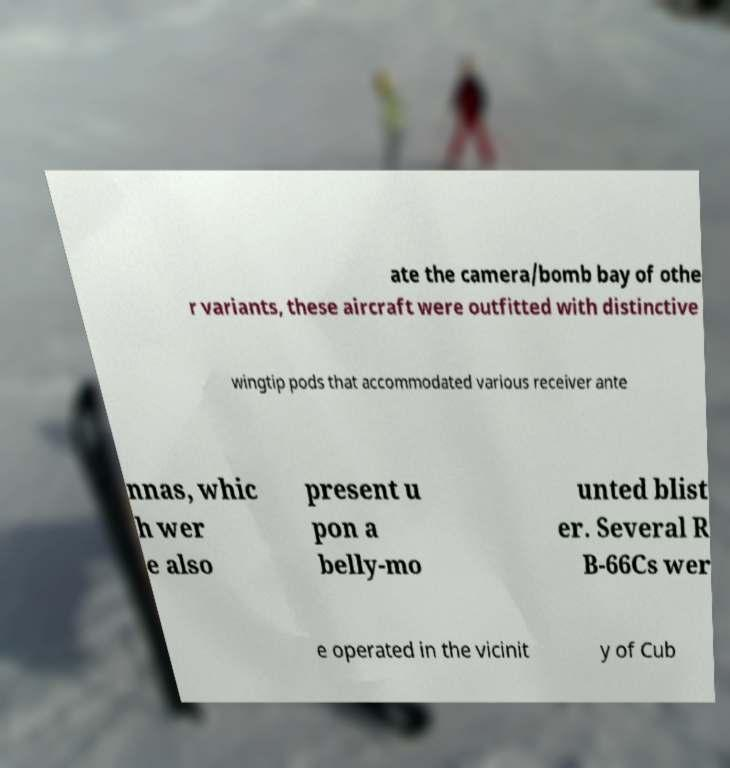I need the written content from this picture converted into text. Can you do that? ate the camera/bomb bay of othe r variants, these aircraft were outfitted with distinctive wingtip pods that accommodated various receiver ante nnas, whic h wer e also present u pon a belly-mo unted blist er. Several R B-66Cs wer e operated in the vicinit y of Cub 